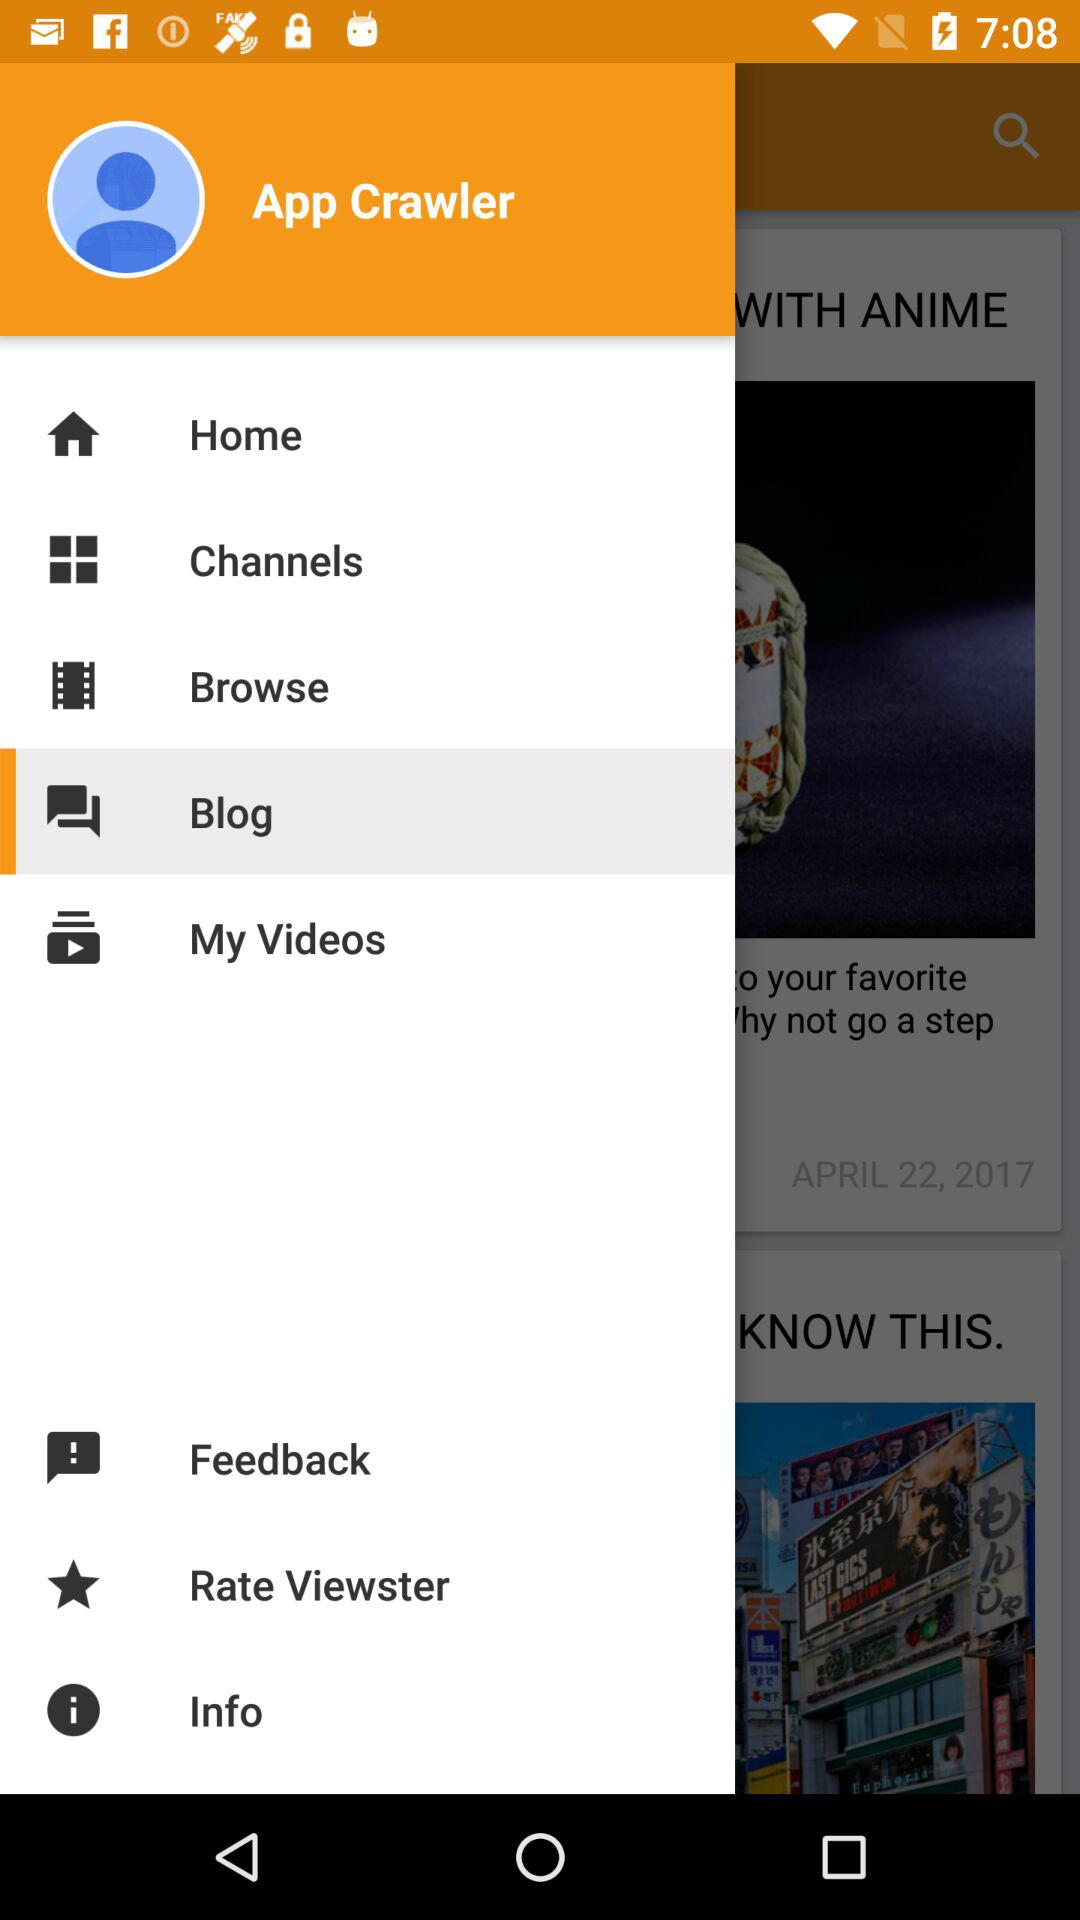Which is the selected item in the menu? The selected item in the menu is "Blog". 